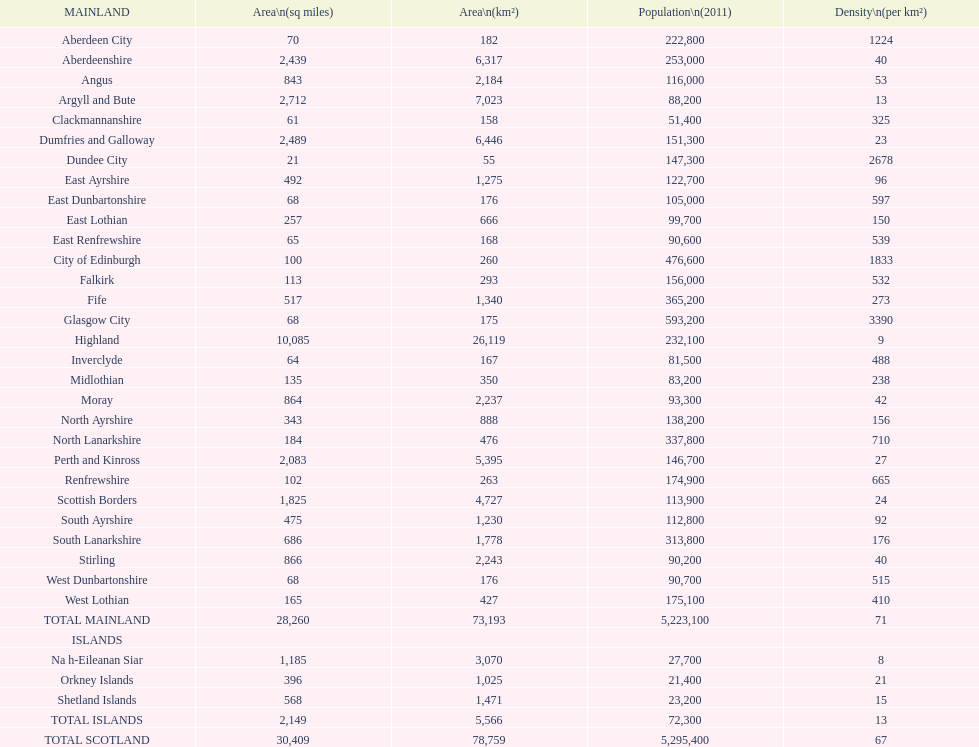In mainland urban areas, what is the usual population density? 71. 